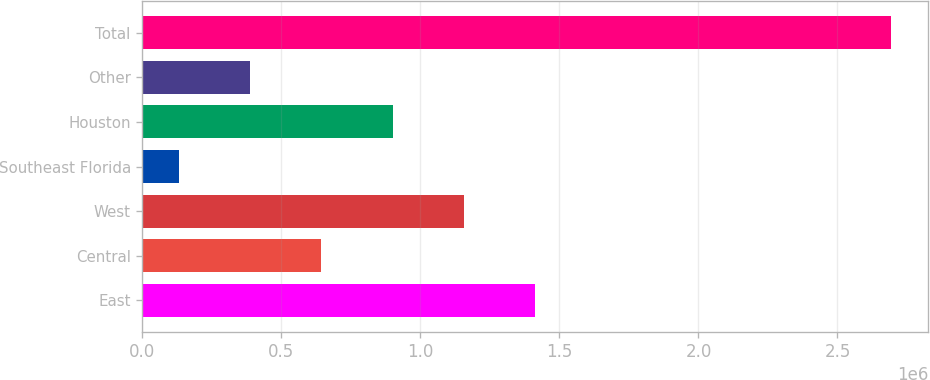Convert chart to OTSL. <chart><loc_0><loc_0><loc_500><loc_500><bar_chart><fcel>East<fcel>Central<fcel>West<fcel>Southeast Florida<fcel>Houston<fcel>Other<fcel>Total<nl><fcel>1.41169e+06<fcel>643331<fcel>1.15557e+06<fcel>131091<fcel>899451<fcel>387211<fcel>2.69229e+06<nl></chart> 